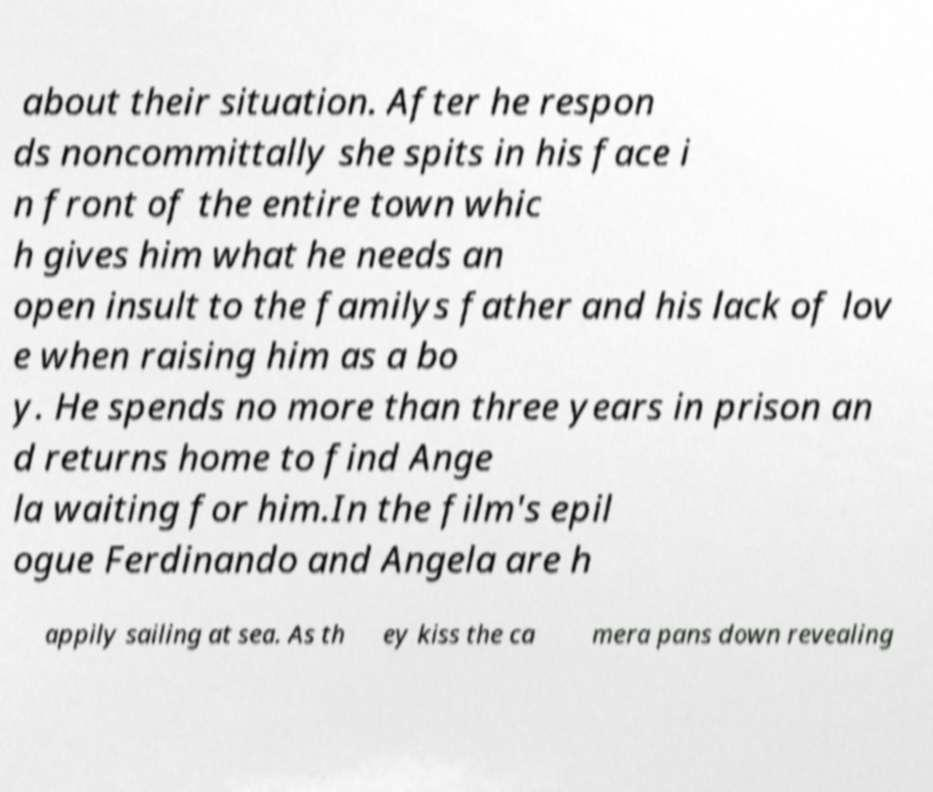There's text embedded in this image that I need extracted. Can you transcribe it verbatim? about their situation. After he respon ds noncommittally she spits in his face i n front of the entire town whic h gives him what he needs an open insult to the familys father and his lack of lov e when raising him as a bo y. He spends no more than three years in prison an d returns home to find Ange la waiting for him.In the film's epil ogue Ferdinando and Angela are h appily sailing at sea. As th ey kiss the ca mera pans down revealing 